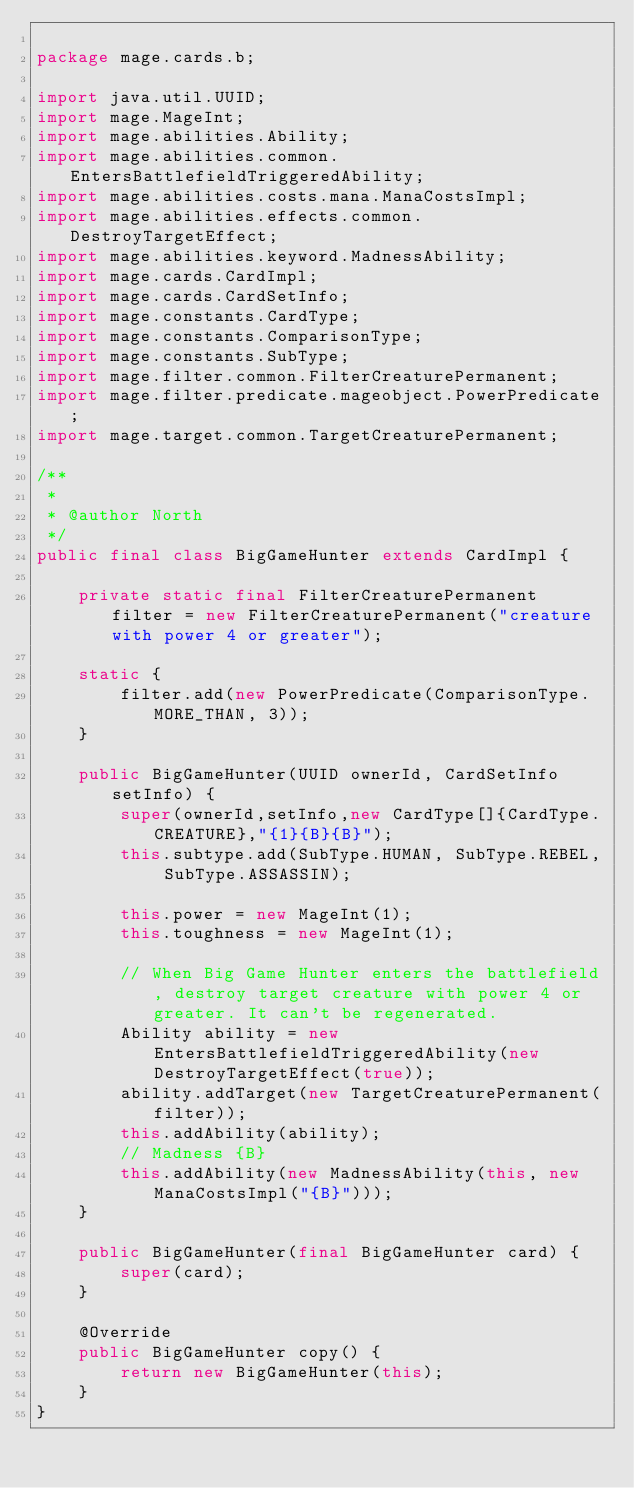Convert code to text. <code><loc_0><loc_0><loc_500><loc_500><_Java_>
package mage.cards.b;

import java.util.UUID;
import mage.MageInt;
import mage.abilities.Ability;
import mage.abilities.common.EntersBattlefieldTriggeredAbility;
import mage.abilities.costs.mana.ManaCostsImpl;
import mage.abilities.effects.common.DestroyTargetEffect;
import mage.abilities.keyword.MadnessAbility;
import mage.cards.CardImpl;
import mage.cards.CardSetInfo;
import mage.constants.CardType;
import mage.constants.ComparisonType;
import mage.constants.SubType;
import mage.filter.common.FilterCreaturePermanent;
import mage.filter.predicate.mageobject.PowerPredicate;
import mage.target.common.TargetCreaturePermanent;

/**
 *
 * @author North
 */
public final class BigGameHunter extends CardImpl {

    private static final FilterCreaturePermanent filter = new FilterCreaturePermanent("creature with power 4 or greater");

    static {
        filter.add(new PowerPredicate(ComparisonType.MORE_THAN, 3));
    }

    public BigGameHunter(UUID ownerId, CardSetInfo setInfo) {
        super(ownerId,setInfo,new CardType[]{CardType.CREATURE},"{1}{B}{B}");
        this.subtype.add(SubType.HUMAN, SubType.REBEL, SubType.ASSASSIN);

        this.power = new MageInt(1);
        this.toughness = new MageInt(1);

        // When Big Game Hunter enters the battlefield, destroy target creature with power 4 or greater. It can't be regenerated.
        Ability ability = new EntersBattlefieldTriggeredAbility(new DestroyTargetEffect(true));
        ability.addTarget(new TargetCreaturePermanent(filter));
        this.addAbility(ability);
        // Madness {B}
        this.addAbility(new MadnessAbility(this, new ManaCostsImpl("{B}")));
    }

    public BigGameHunter(final BigGameHunter card) {
        super(card);
    }

    @Override
    public BigGameHunter copy() {
        return new BigGameHunter(this);
    }
}
</code> 